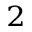Convert formula to latex. <formula><loc_0><loc_0><loc_500><loc_500>_ { 2 }</formula> 